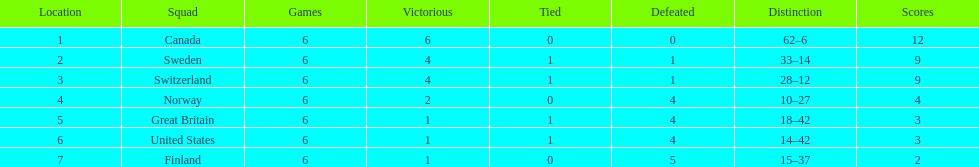What team placed next after sweden? Switzerland. 